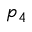Convert formula to latex. <formula><loc_0><loc_0><loc_500><loc_500>p _ { 4 }</formula> 